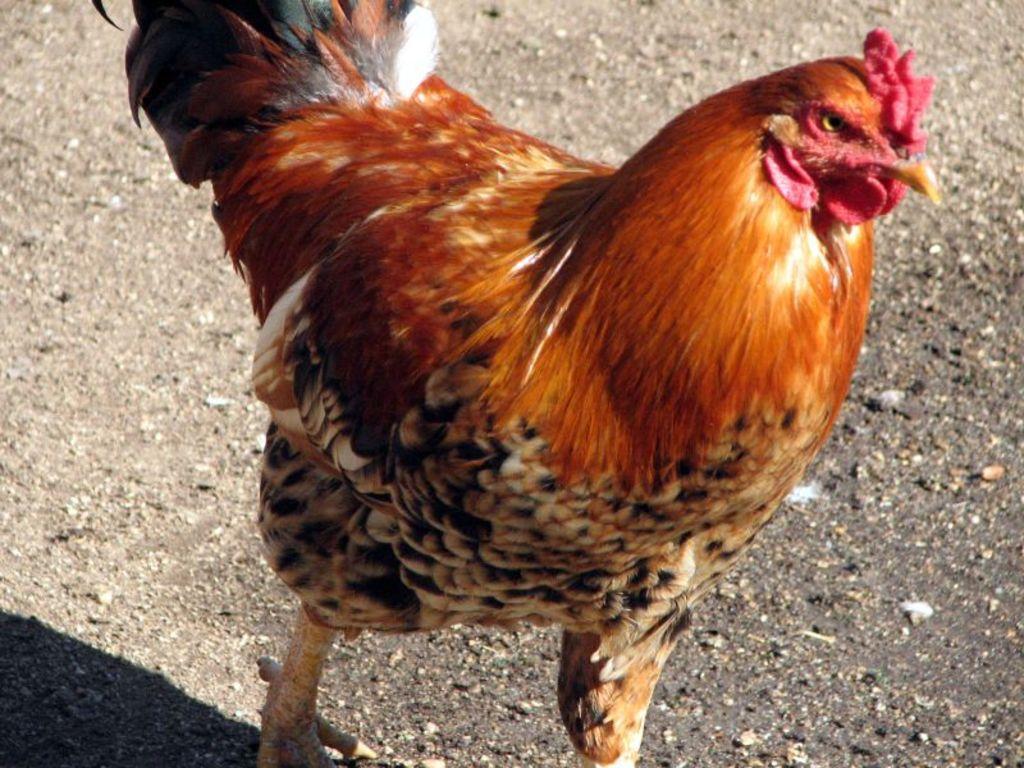Please provide a concise description of this image. In this picture I can observe rooster. It is in brown, black and cream colors. In the background I can observe land. 